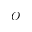Convert formula to latex. <formula><loc_0><loc_0><loc_500><loc_500>O</formula> 